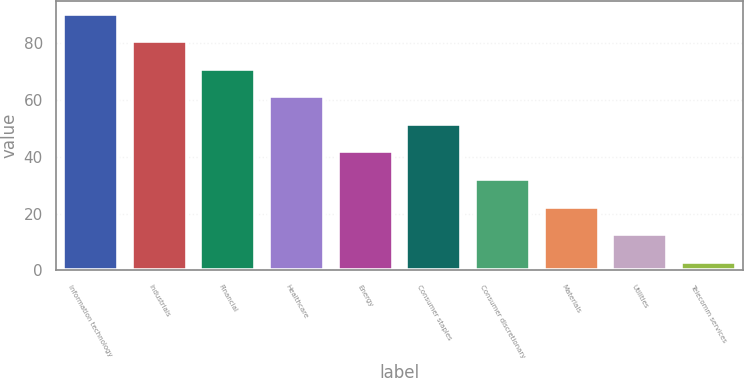Convert chart. <chart><loc_0><loc_0><loc_500><loc_500><bar_chart><fcel>Information technology<fcel>Industrials<fcel>Financial<fcel>Healthcare<fcel>Energy<fcel>Consumer staples<fcel>Consumer discretionary<fcel>Materials<fcel>Utilities<fcel>Telecomm services<nl><fcel>90.31<fcel>80.62<fcel>70.93<fcel>61.24<fcel>41.86<fcel>51.55<fcel>32.17<fcel>22.48<fcel>12.79<fcel>3.1<nl></chart> 